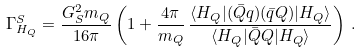Convert formula to latex. <formula><loc_0><loc_0><loc_500><loc_500>\Gamma _ { H _ { Q } } ^ { S } = \frac { G _ { S } ^ { 2 } m _ { Q } } { 1 6 \pi } \left ( 1 + \frac { 4 \pi } { m _ { Q } } \, \frac { \langle H _ { Q } | ( \bar { Q } q ) ( \bar { q } Q ) | H _ { Q } \rangle } { \langle H _ { Q } | \bar { Q } Q | H _ { Q } \rangle } \right ) \, .</formula> 